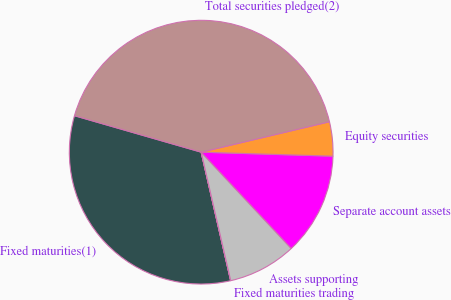Convert chart to OTSL. <chart><loc_0><loc_0><loc_500><loc_500><pie_chart><fcel>Fixed maturities(1)<fcel>Fixed maturities trading<fcel>Assets supporting<fcel>Separate account assets<fcel>Equity securities<fcel>Total securities pledged(2)<nl><fcel>33.05%<fcel>0.01%<fcel>8.37%<fcel>12.55%<fcel>4.19%<fcel>41.83%<nl></chart> 